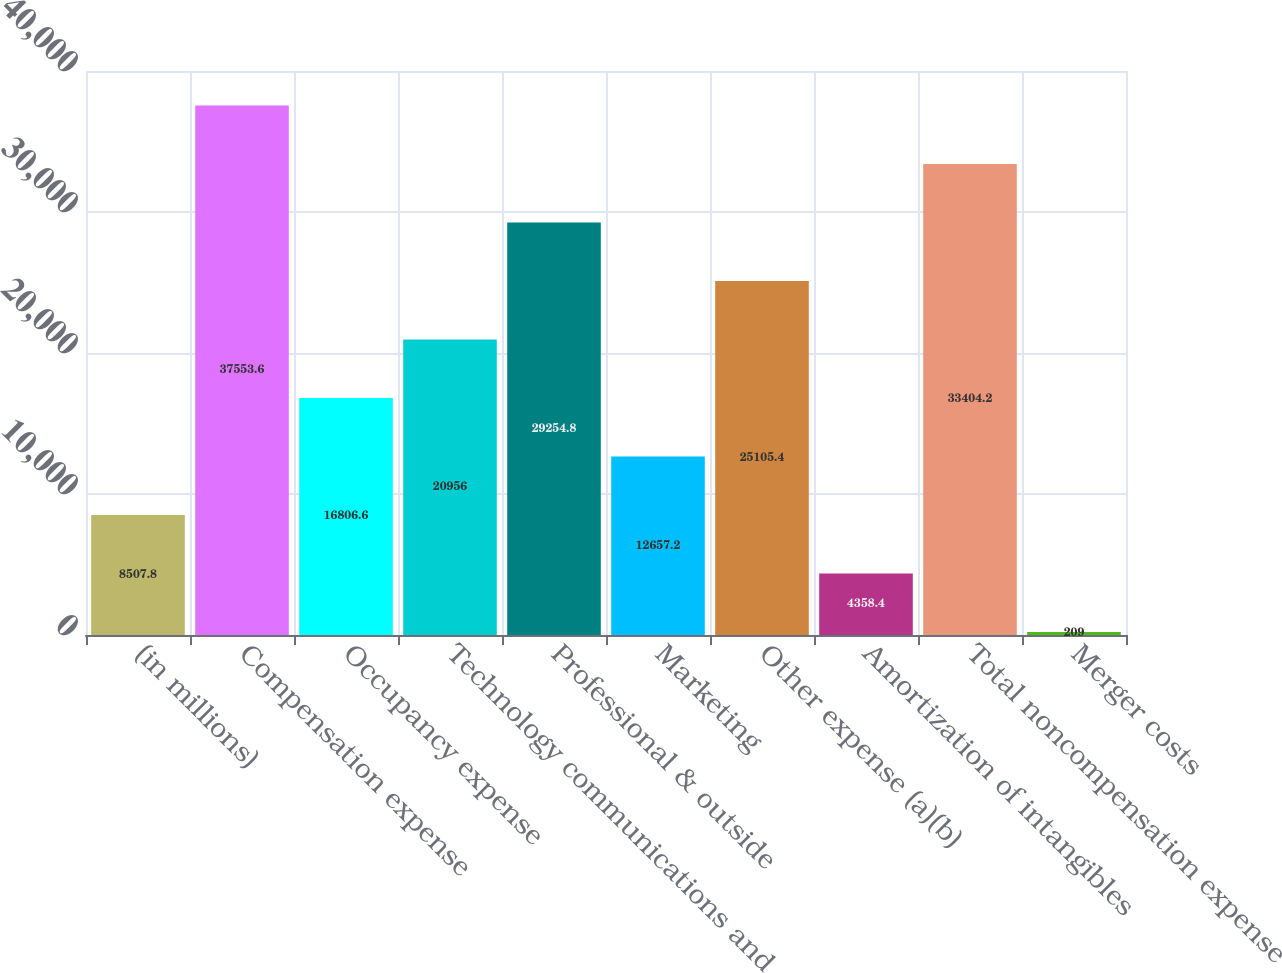Convert chart. <chart><loc_0><loc_0><loc_500><loc_500><bar_chart><fcel>(in millions)<fcel>Compensation expense<fcel>Occupancy expense<fcel>Technology communications and<fcel>Professional & outside<fcel>Marketing<fcel>Other expense (a)(b)<fcel>Amortization of intangibles<fcel>Total noncompensation expense<fcel>Merger costs<nl><fcel>8507.8<fcel>37553.6<fcel>16806.6<fcel>20956<fcel>29254.8<fcel>12657.2<fcel>25105.4<fcel>4358.4<fcel>33404.2<fcel>209<nl></chart> 